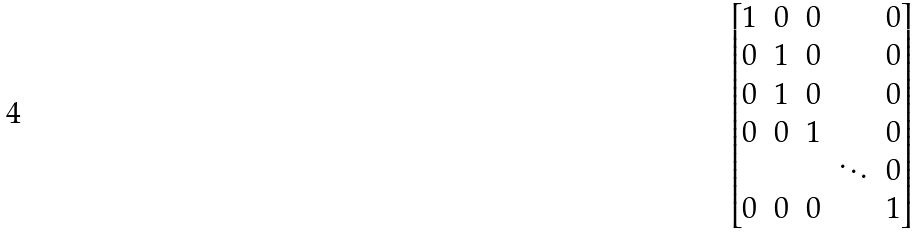<formula> <loc_0><loc_0><loc_500><loc_500>\begin{bmatrix} 1 & 0 & 0 & & 0 \\ 0 & 1 & 0 & & 0 \\ 0 & 1 & 0 & & 0 \\ 0 & 0 & 1 & & 0 \\ & & & \ddots & 0 \\ 0 & 0 & 0 & & 1 \end{bmatrix}</formula> 